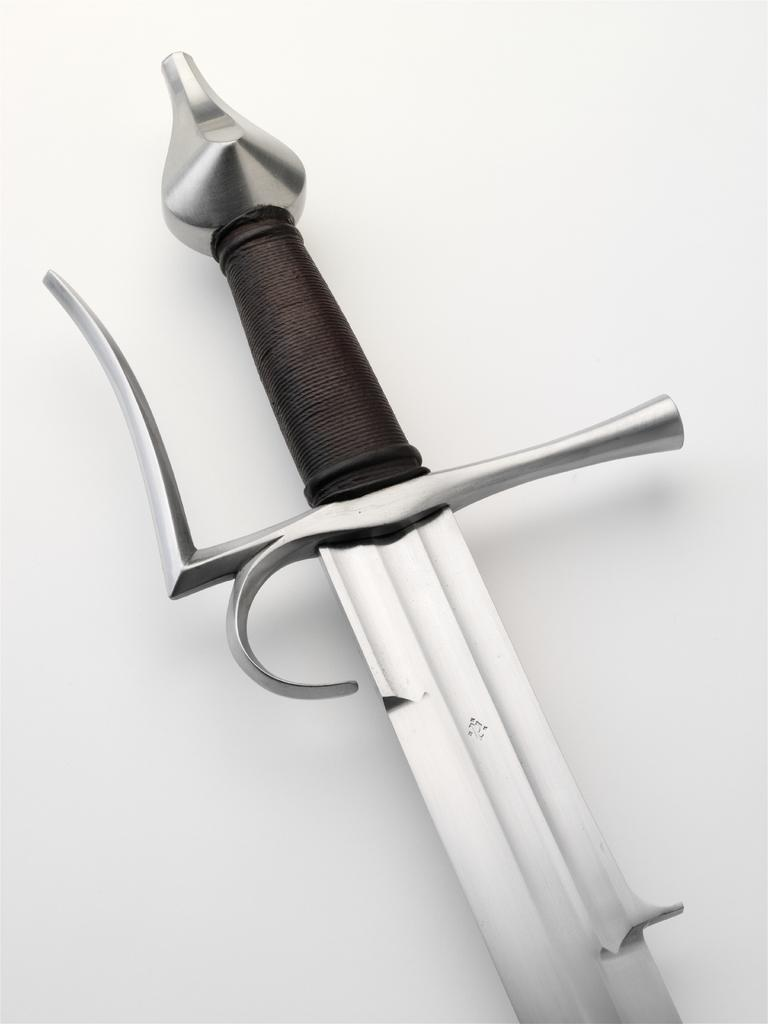What object is visible in the image? There is a sword present in the image. What is the color of the surface on which the sword is placed? The sword is on a white surface. What type of trains are participating in the competition in the image? There are no trains or competition present in the image; it features a sword on a white surface. What type of laborer is depicted working with the sword in the image? There is no laborer present in the image; it only features a sword on a white surface. 